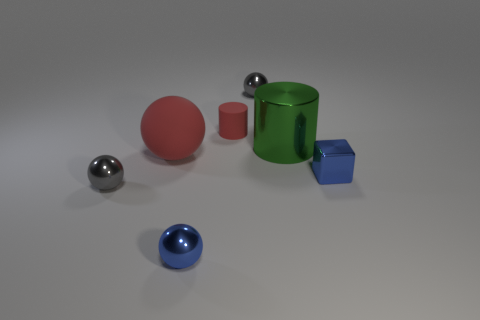Subtract all red cylinders. How many gray spheres are left? 2 Subtract all red balls. How many balls are left? 3 Subtract 2 spheres. How many spheres are left? 2 Subtract all red balls. How many balls are left? 3 Add 1 red cylinders. How many objects exist? 8 Subtract all brown spheres. Subtract all brown cylinders. How many spheres are left? 4 Subtract all cylinders. How many objects are left? 5 Add 5 large blue matte balls. How many large blue matte balls exist? 5 Subtract 1 gray balls. How many objects are left? 6 Subtract all small gray balls. Subtract all cubes. How many objects are left? 4 